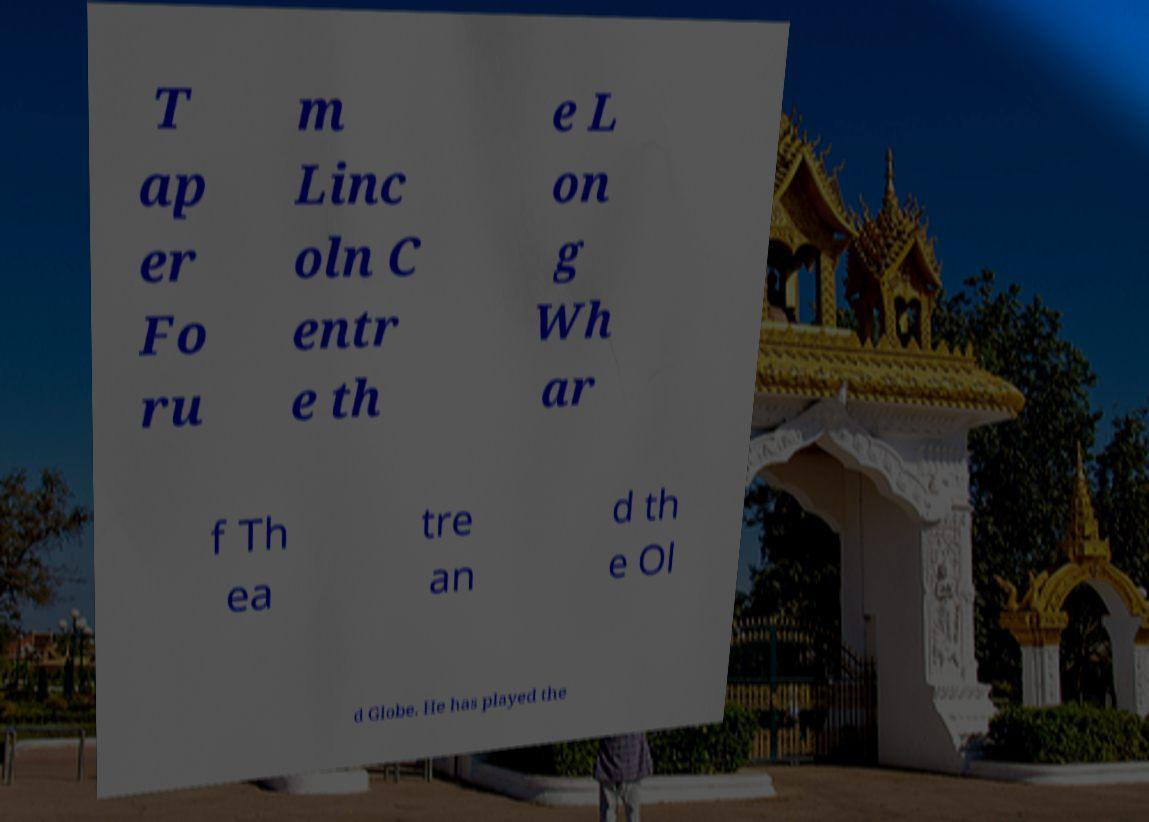Please read and relay the text visible in this image. What does it say? T ap er Fo ru m Linc oln C entr e th e L on g Wh ar f Th ea tre an d th e Ol d Globe. He has played the 